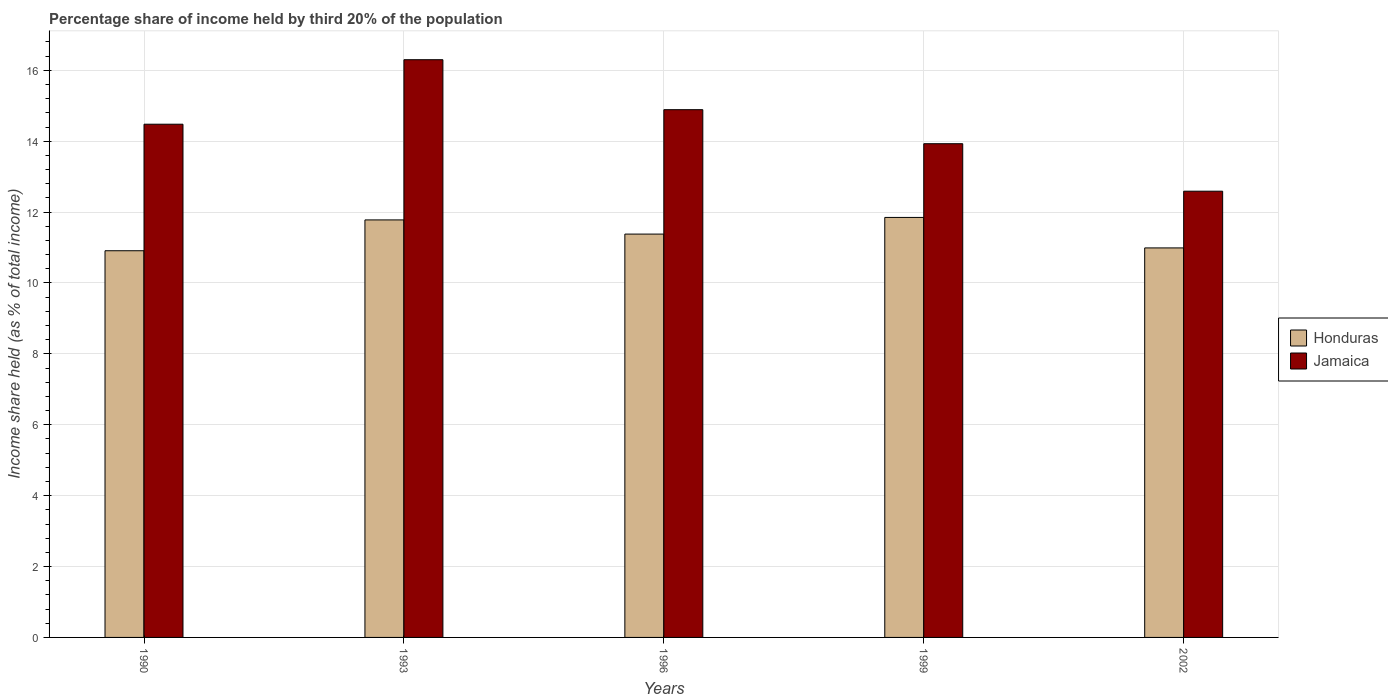How many different coloured bars are there?
Your answer should be very brief. 2. Are the number of bars on each tick of the X-axis equal?
Offer a very short reply. Yes. What is the label of the 1st group of bars from the left?
Your answer should be very brief. 1990. What is the share of income held by third 20% of the population in Honduras in 1993?
Provide a short and direct response. 11.78. Across all years, what is the maximum share of income held by third 20% of the population in Jamaica?
Keep it short and to the point. 16.3. Across all years, what is the minimum share of income held by third 20% of the population in Jamaica?
Your answer should be compact. 12.59. In which year was the share of income held by third 20% of the population in Jamaica maximum?
Your answer should be compact. 1993. What is the total share of income held by third 20% of the population in Jamaica in the graph?
Ensure brevity in your answer.  72.19. What is the difference between the share of income held by third 20% of the population in Honduras in 1996 and that in 1999?
Provide a short and direct response. -0.47. What is the difference between the share of income held by third 20% of the population in Jamaica in 1993 and the share of income held by third 20% of the population in Honduras in 1999?
Keep it short and to the point. 4.45. What is the average share of income held by third 20% of the population in Honduras per year?
Offer a terse response. 11.38. In the year 1996, what is the difference between the share of income held by third 20% of the population in Honduras and share of income held by third 20% of the population in Jamaica?
Ensure brevity in your answer.  -3.51. In how many years, is the share of income held by third 20% of the population in Jamaica greater than 12.4 %?
Your answer should be compact. 5. What is the ratio of the share of income held by third 20% of the population in Jamaica in 1996 to that in 2002?
Your response must be concise. 1.18. What is the difference between the highest and the second highest share of income held by third 20% of the population in Jamaica?
Your answer should be very brief. 1.41. What is the difference between the highest and the lowest share of income held by third 20% of the population in Jamaica?
Offer a terse response. 3.71. In how many years, is the share of income held by third 20% of the population in Honduras greater than the average share of income held by third 20% of the population in Honduras taken over all years?
Make the answer very short. 2. What does the 1st bar from the left in 1999 represents?
Offer a terse response. Honduras. What does the 1st bar from the right in 1996 represents?
Ensure brevity in your answer.  Jamaica. How many bars are there?
Provide a short and direct response. 10. Are all the bars in the graph horizontal?
Keep it short and to the point. No. What is the difference between two consecutive major ticks on the Y-axis?
Offer a very short reply. 2. How are the legend labels stacked?
Offer a terse response. Vertical. What is the title of the graph?
Ensure brevity in your answer.  Percentage share of income held by third 20% of the population. What is the label or title of the X-axis?
Ensure brevity in your answer.  Years. What is the label or title of the Y-axis?
Give a very brief answer. Income share held (as % of total income). What is the Income share held (as % of total income) in Honduras in 1990?
Your answer should be very brief. 10.91. What is the Income share held (as % of total income) in Jamaica in 1990?
Offer a terse response. 14.48. What is the Income share held (as % of total income) in Honduras in 1993?
Provide a short and direct response. 11.78. What is the Income share held (as % of total income) in Jamaica in 1993?
Ensure brevity in your answer.  16.3. What is the Income share held (as % of total income) in Honduras in 1996?
Offer a very short reply. 11.38. What is the Income share held (as % of total income) in Jamaica in 1996?
Provide a short and direct response. 14.89. What is the Income share held (as % of total income) of Honduras in 1999?
Your answer should be compact. 11.85. What is the Income share held (as % of total income) of Jamaica in 1999?
Give a very brief answer. 13.93. What is the Income share held (as % of total income) in Honduras in 2002?
Offer a terse response. 10.99. What is the Income share held (as % of total income) of Jamaica in 2002?
Provide a succinct answer. 12.59. Across all years, what is the maximum Income share held (as % of total income) of Honduras?
Give a very brief answer. 11.85. Across all years, what is the maximum Income share held (as % of total income) of Jamaica?
Your answer should be very brief. 16.3. Across all years, what is the minimum Income share held (as % of total income) of Honduras?
Your answer should be compact. 10.91. Across all years, what is the minimum Income share held (as % of total income) of Jamaica?
Your response must be concise. 12.59. What is the total Income share held (as % of total income) in Honduras in the graph?
Your answer should be compact. 56.91. What is the total Income share held (as % of total income) in Jamaica in the graph?
Your answer should be very brief. 72.19. What is the difference between the Income share held (as % of total income) in Honduras in 1990 and that in 1993?
Provide a short and direct response. -0.87. What is the difference between the Income share held (as % of total income) in Jamaica in 1990 and that in 1993?
Offer a very short reply. -1.82. What is the difference between the Income share held (as % of total income) of Honduras in 1990 and that in 1996?
Ensure brevity in your answer.  -0.47. What is the difference between the Income share held (as % of total income) of Jamaica in 1990 and that in 1996?
Make the answer very short. -0.41. What is the difference between the Income share held (as % of total income) in Honduras in 1990 and that in 1999?
Your answer should be very brief. -0.94. What is the difference between the Income share held (as % of total income) of Jamaica in 1990 and that in 1999?
Provide a short and direct response. 0.55. What is the difference between the Income share held (as % of total income) in Honduras in 1990 and that in 2002?
Your answer should be compact. -0.08. What is the difference between the Income share held (as % of total income) in Jamaica in 1990 and that in 2002?
Provide a succinct answer. 1.89. What is the difference between the Income share held (as % of total income) in Jamaica in 1993 and that in 1996?
Your response must be concise. 1.41. What is the difference between the Income share held (as % of total income) in Honduras in 1993 and that in 1999?
Make the answer very short. -0.07. What is the difference between the Income share held (as % of total income) of Jamaica in 1993 and that in 1999?
Keep it short and to the point. 2.37. What is the difference between the Income share held (as % of total income) of Honduras in 1993 and that in 2002?
Your answer should be compact. 0.79. What is the difference between the Income share held (as % of total income) in Jamaica in 1993 and that in 2002?
Offer a very short reply. 3.71. What is the difference between the Income share held (as % of total income) of Honduras in 1996 and that in 1999?
Give a very brief answer. -0.47. What is the difference between the Income share held (as % of total income) in Jamaica in 1996 and that in 1999?
Offer a very short reply. 0.96. What is the difference between the Income share held (as % of total income) of Honduras in 1996 and that in 2002?
Your response must be concise. 0.39. What is the difference between the Income share held (as % of total income) of Honduras in 1999 and that in 2002?
Offer a terse response. 0.86. What is the difference between the Income share held (as % of total income) of Jamaica in 1999 and that in 2002?
Offer a terse response. 1.34. What is the difference between the Income share held (as % of total income) of Honduras in 1990 and the Income share held (as % of total income) of Jamaica in 1993?
Ensure brevity in your answer.  -5.39. What is the difference between the Income share held (as % of total income) in Honduras in 1990 and the Income share held (as % of total income) in Jamaica in 1996?
Give a very brief answer. -3.98. What is the difference between the Income share held (as % of total income) of Honduras in 1990 and the Income share held (as % of total income) of Jamaica in 1999?
Provide a succinct answer. -3.02. What is the difference between the Income share held (as % of total income) in Honduras in 1990 and the Income share held (as % of total income) in Jamaica in 2002?
Ensure brevity in your answer.  -1.68. What is the difference between the Income share held (as % of total income) in Honduras in 1993 and the Income share held (as % of total income) in Jamaica in 1996?
Ensure brevity in your answer.  -3.11. What is the difference between the Income share held (as % of total income) in Honduras in 1993 and the Income share held (as % of total income) in Jamaica in 1999?
Your response must be concise. -2.15. What is the difference between the Income share held (as % of total income) in Honduras in 1993 and the Income share held (as % of total income) in Jamaica in 2002?
Your answer should be compact. -0.81. What is the difference between the Income share held (as % of total income) of Honduras in 1996 and the Income share held (as % of total income) of Jamaica in 1999?
Give a very brief answer. -2.55. What is the difference between the Income share held (as % of total income) of Honduras in 1996 and the Income share held (as % of total income) of Jamaica in 2002?
Offer a very short reply. -1.21. What is the difference between the Income share held (as % of total income) of Honduras in 1999 and the Income share held (as % of total income) of Jamaica in 2002?
Keep it short and to the point. -0.74. What is the average Income share held (as % of total income) of Honduras per year?
Keep it short and to the point. 11.38. What is the average Income share held (as % of total income) of Jamaica per year?
Provide a succinct answer. 14.44. In the year 1990, what is the difference between the Income share held (as % of total income) of Honduras and Income share held (as % of total income) of Jamaica?
Make the answer very short. -3.57. In the year 1993, what is the difference between the Income share held (as % of total income) in Honduras and Income share held (as % of total income) in Jamaica?
Your answer should be compact. -4.52. In the year 1996, what is the difference between the Income share held (as % of total income) of Honduras and Income share held (as % of total income) of Jamaica?
Make the answer very short. -3.51. In the year 1999, what is the difference between the Income share held (as % of total income) of Honduras and Income share held (as % of total income) of Jamaica?
Keep it short and to the point. -2.08. What is the ratio of the Income share held (as % of total income) in Honduras in 1990 to that in 1993?
Your answer should be compact. 0.93. What is the ratio of the Income share held (as % of total income) in Jamaica in 1990 to that in 1993?
Your answer should be compact. 0.89. What is the ratio of the Income share held (as % of total income) in Honduras in 1990 to that in 1996?
Offer a terse response. 0.96. What is the ratio of the Income share held (as % of total income) in Jamaica in 1990 to that in 1996?
Provide a short and direct response. 0.97. What is the ratio of the Income share held (as % of total income) of Honduras in 1990 to that in 1999?
Offer a very short reply. 0.92. What is the ratio of the Income share held (as % of total income) in Jamaica in 1990 to that in 1999?
Keep it short and to the point. 1.04. What is the ratio of the Income share held (as % of total income) of Jamaica in 1990 to that in 2002?
Ensure brevity in your answer.  1.15. What is the ratio of the Income share held (as % of total income) of Honduras in 1993 to that in 1996?
Provide a short and direct response. 1.04. What is the ratio of the Income share held (as % of total income) of Jamaica in 1993 to that in 1996?
Your answer should be compact. 1.09. What is the ratio of the Income share held (as % of total income) in Jamaica in 1993 to that in 1999?
Offer a very short reply. 1.17. What is the ratio of the Income share held (as % of total income) in Honduras in 1993 to that in 2002?
Your response must be concise. 1.07. What is the ratio of the Income share held (as % of total income) of Jamaica in 1993 to that in 2002?
Provide a succinct answer. 1.29. What is the ratio of the Income share held (as % of total income) of Honduras in 1996 to that in 1999?
Provide a succinct answer. 0.96. What is the ratio of the Income share held (as % of total income) of Jamaica in 1996 to that in 1999?
Your answer should be compact. 1.07. What is the ratio of the Income share held (as % of total income) in Honduras in 1996 to that in 2002?
Your answer should be very brief. 1.04. What is the ratio of the Income share held (as % of total income) in Jamaica in 1996 to that in 2002?
Give a very brief answer. 1.18. What is the ratio of the Income share held (as % of total income) of Honduras in 1999 to that in 2002?
Make the answer very short. 1.08. What is the ratio of the Income share held (as % of total income) in Jamaica in 1999 to that in 2002?
Your answer should be compact. 1.11. What is the difference between the highest and the second highest Income share held (as % of total income) of Honduras?
Keep it short and to the point. 0.07. What is the difference between the highest and the second highest Income share held (as % of total income) in Jamaica?
Offer a terse response. 1.41. What is the difference between the highest and the lowest Income share held (as % of total income) of Honduras?
Offer a terse response. 0.94. What is the difference between the highest and the lowest Income share held (as % of total income) of Jamaica?
Keep it short and to the point. 3.71. 